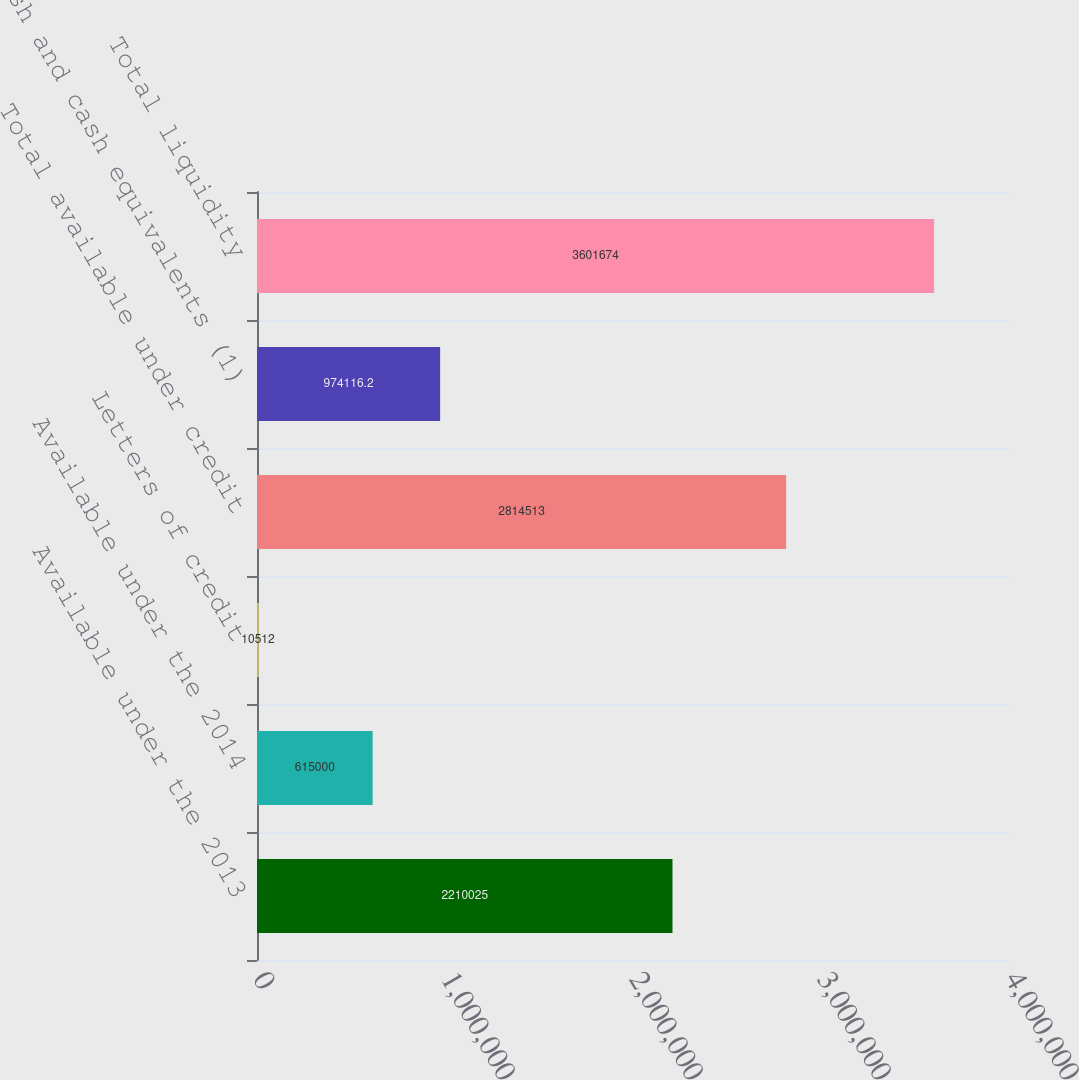Convert chart. <chart><loc_0><loc_0><loc_500><loc_500><bar_chart><fcel>Available under the 2013<fcel>Available under the 2014<fcel>Letters of credit<fcel>Total available under credit<fcel>Cash and cash equivalents (1)<fcel>Total liquidity<nl><fcel>2.21002e+06<fcel>615000<fcel>10512<fcel>2.81451e+06<fcel>974116<fcel>3.60167e+06<nl></chart> 